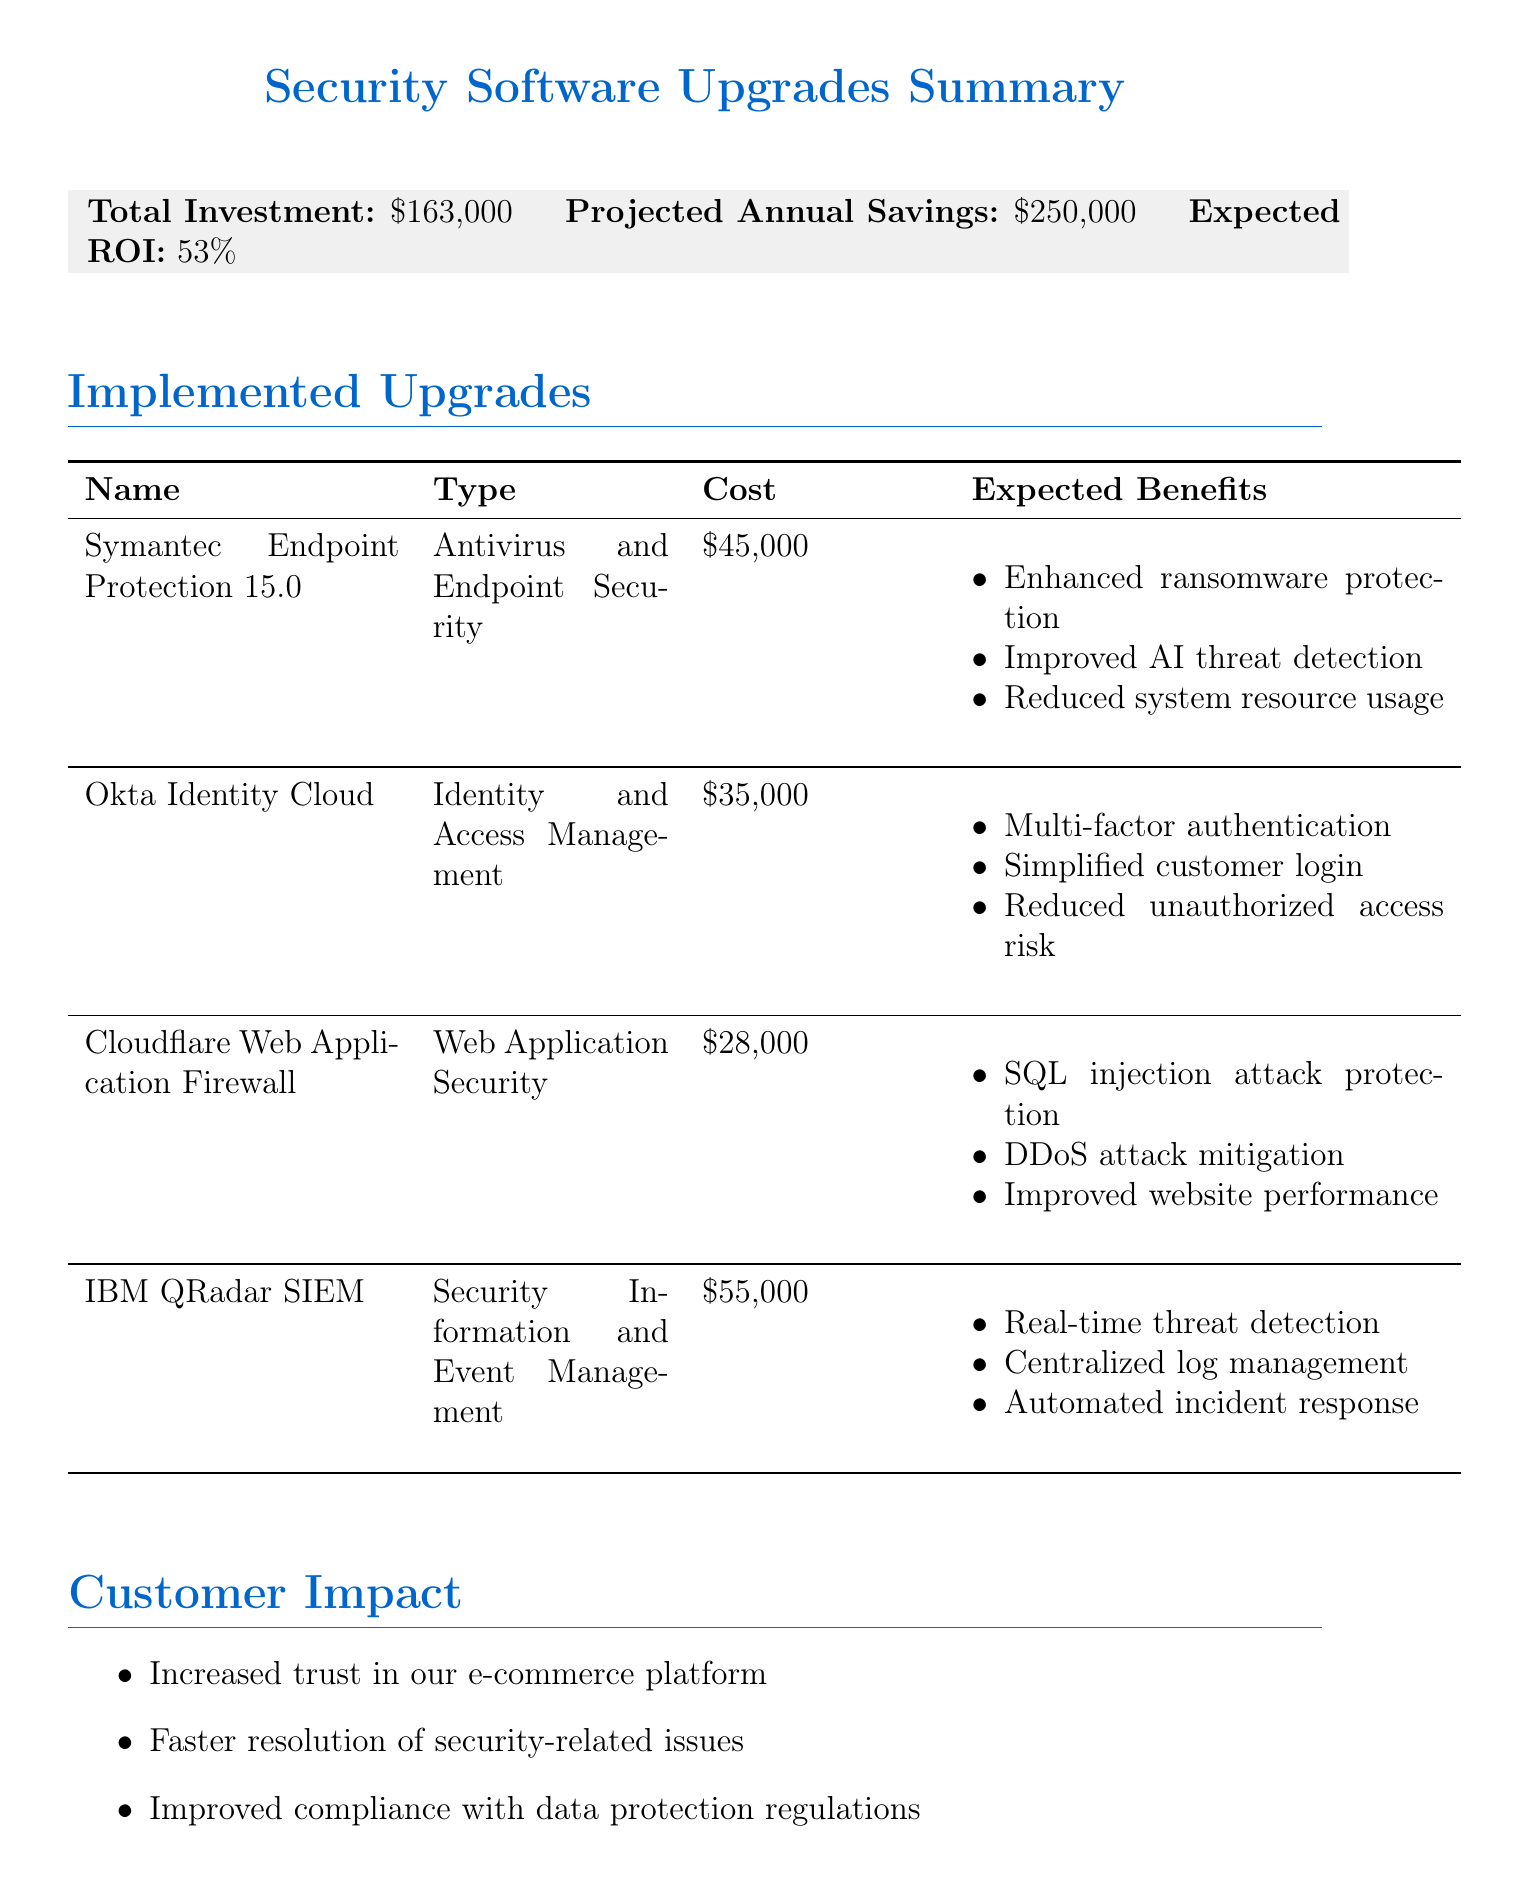what is the total investment for security software upgrades? The total investment is explicitly stated as $163,000 in the document.
Answer: $163,000 what are the expected annual savings from the upgrades? The projected annual savings is mentioned as $250,000 in the document.
Answer: $250,000 how much does the IBM QRadar SIEM upgrade cost? The cost of the IBM QRadar SIEM upgrade is specified as $55,000 in the document.
Answer: $55,000 what is one expected benefit of the Okta Identity Cloud? One of the expected benefits listed is multi-factor authentication for all customer accounts.
Answer: Multi-factor authentication for all customer accounts who will participate in the Okta Identity Cloud Management training? The document states that the participants in this training will be the Customer Support Representatives.
Answer: Customer Support Representatives when does the installation phase of the upgrades start? The installation phase is indicated to begin on March 1, 2023 in the implementation timeline.
Answer: March 1, 2023 what is the expected ROI of the security software upgrades? The expected ROI is expressed as 53% in the document.
Answer: 53% what type of security software upgrade is Cloudflare Web Application Firewall? The type of upgrade is classified as Web Application Security in the document.
Answer: Web Application Security 